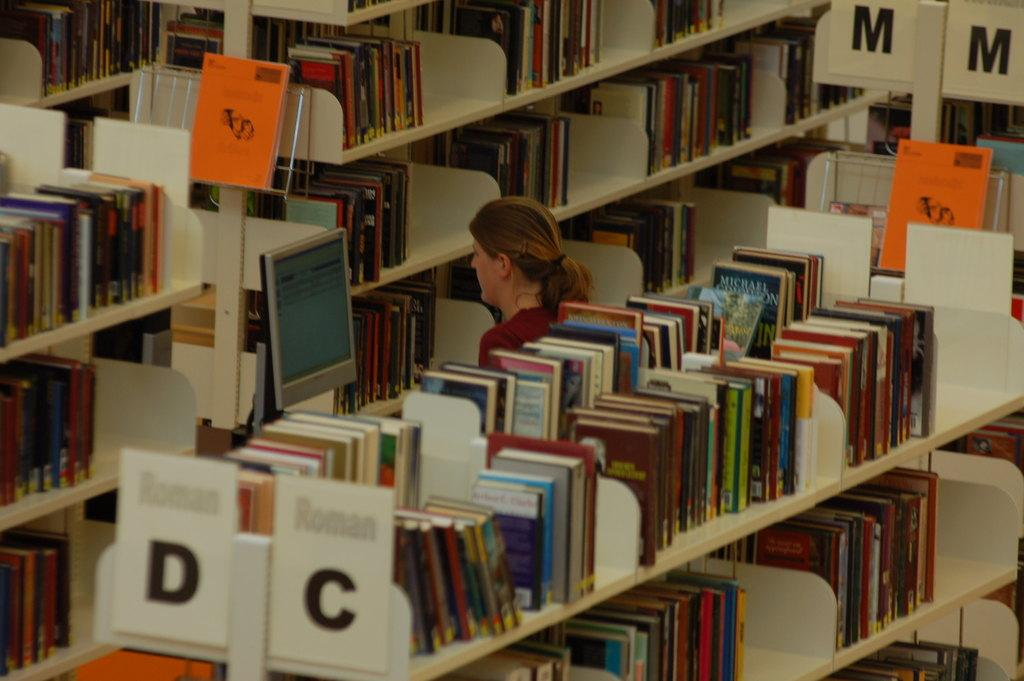Provide a one-sentence caption for the provided image. A library isle with shelves of books for letters D,C and M. 